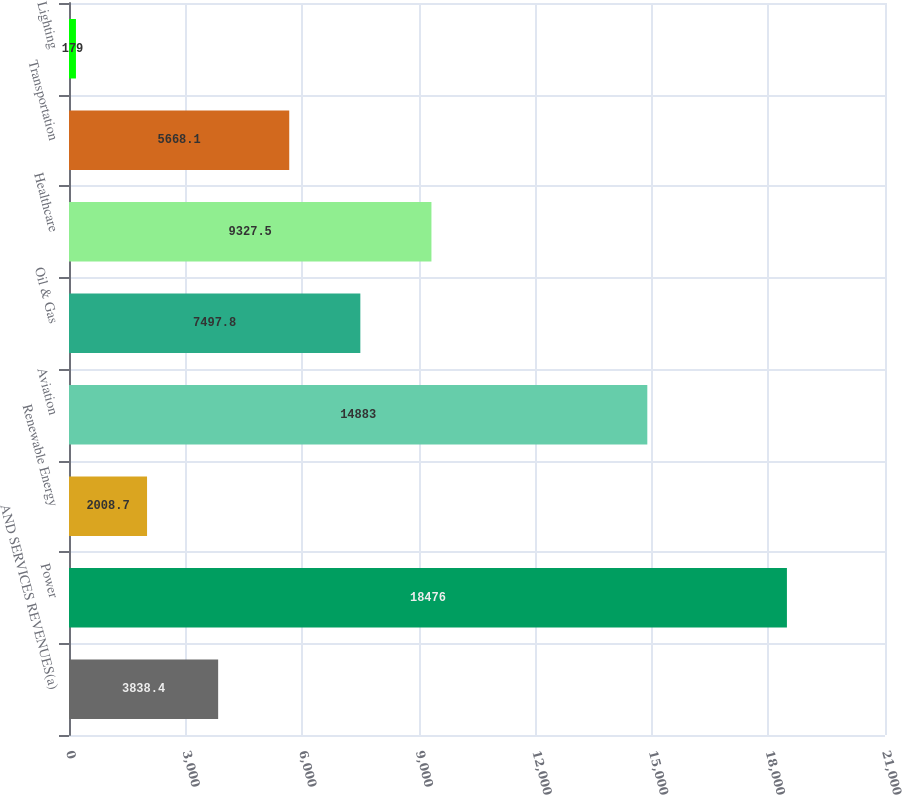Convert chart. <chart><loc_0><loc_0><loc_500><loc_500><bar_chart><fcel>AND SERVICES REVENUES(a)<fcel>Power<fcel>Renewable Energy<fcel>Aviation<fcel>Oil & Gas<fcel>Healthcare<fcel>Transportation<fcel>Lighting<nl><fcel>3838.4<fcel>18476<fcel>2008.7<fcel>14883<fcel>7497.8<fcel>9327.5<fcel>5668.1<fcel>179<nl></chart> 